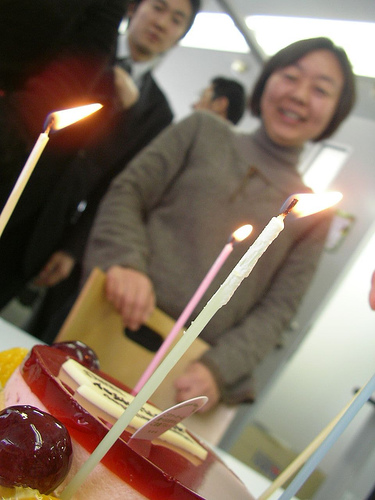What kind of celebration is happening in this picture? It appears to be a birthday celebration, evidenced by the presence of a cake with lit candles, which is customary for such occasions. 